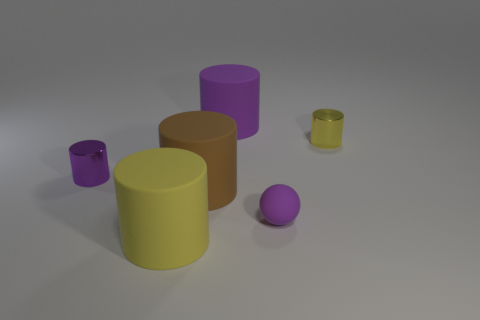In terms of color, which object stands out the most and why? The purple sphere stands out the most due to its vibrant color which has a high contrast against the muted tones of the background and the other objects. 